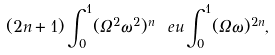<formula> <loc_0><loc_0><loc_500><loc_500>( 2 n + 1 ) \int _ { 0 } ^ { 1 } ( \Omega ^ { 2 } \omega ^ { 2 } ) ^ { n } \ e u \int _ { 0 } ^ { 1 } ( \Omega \omega ) ^ { 2 n } ,</formula> 